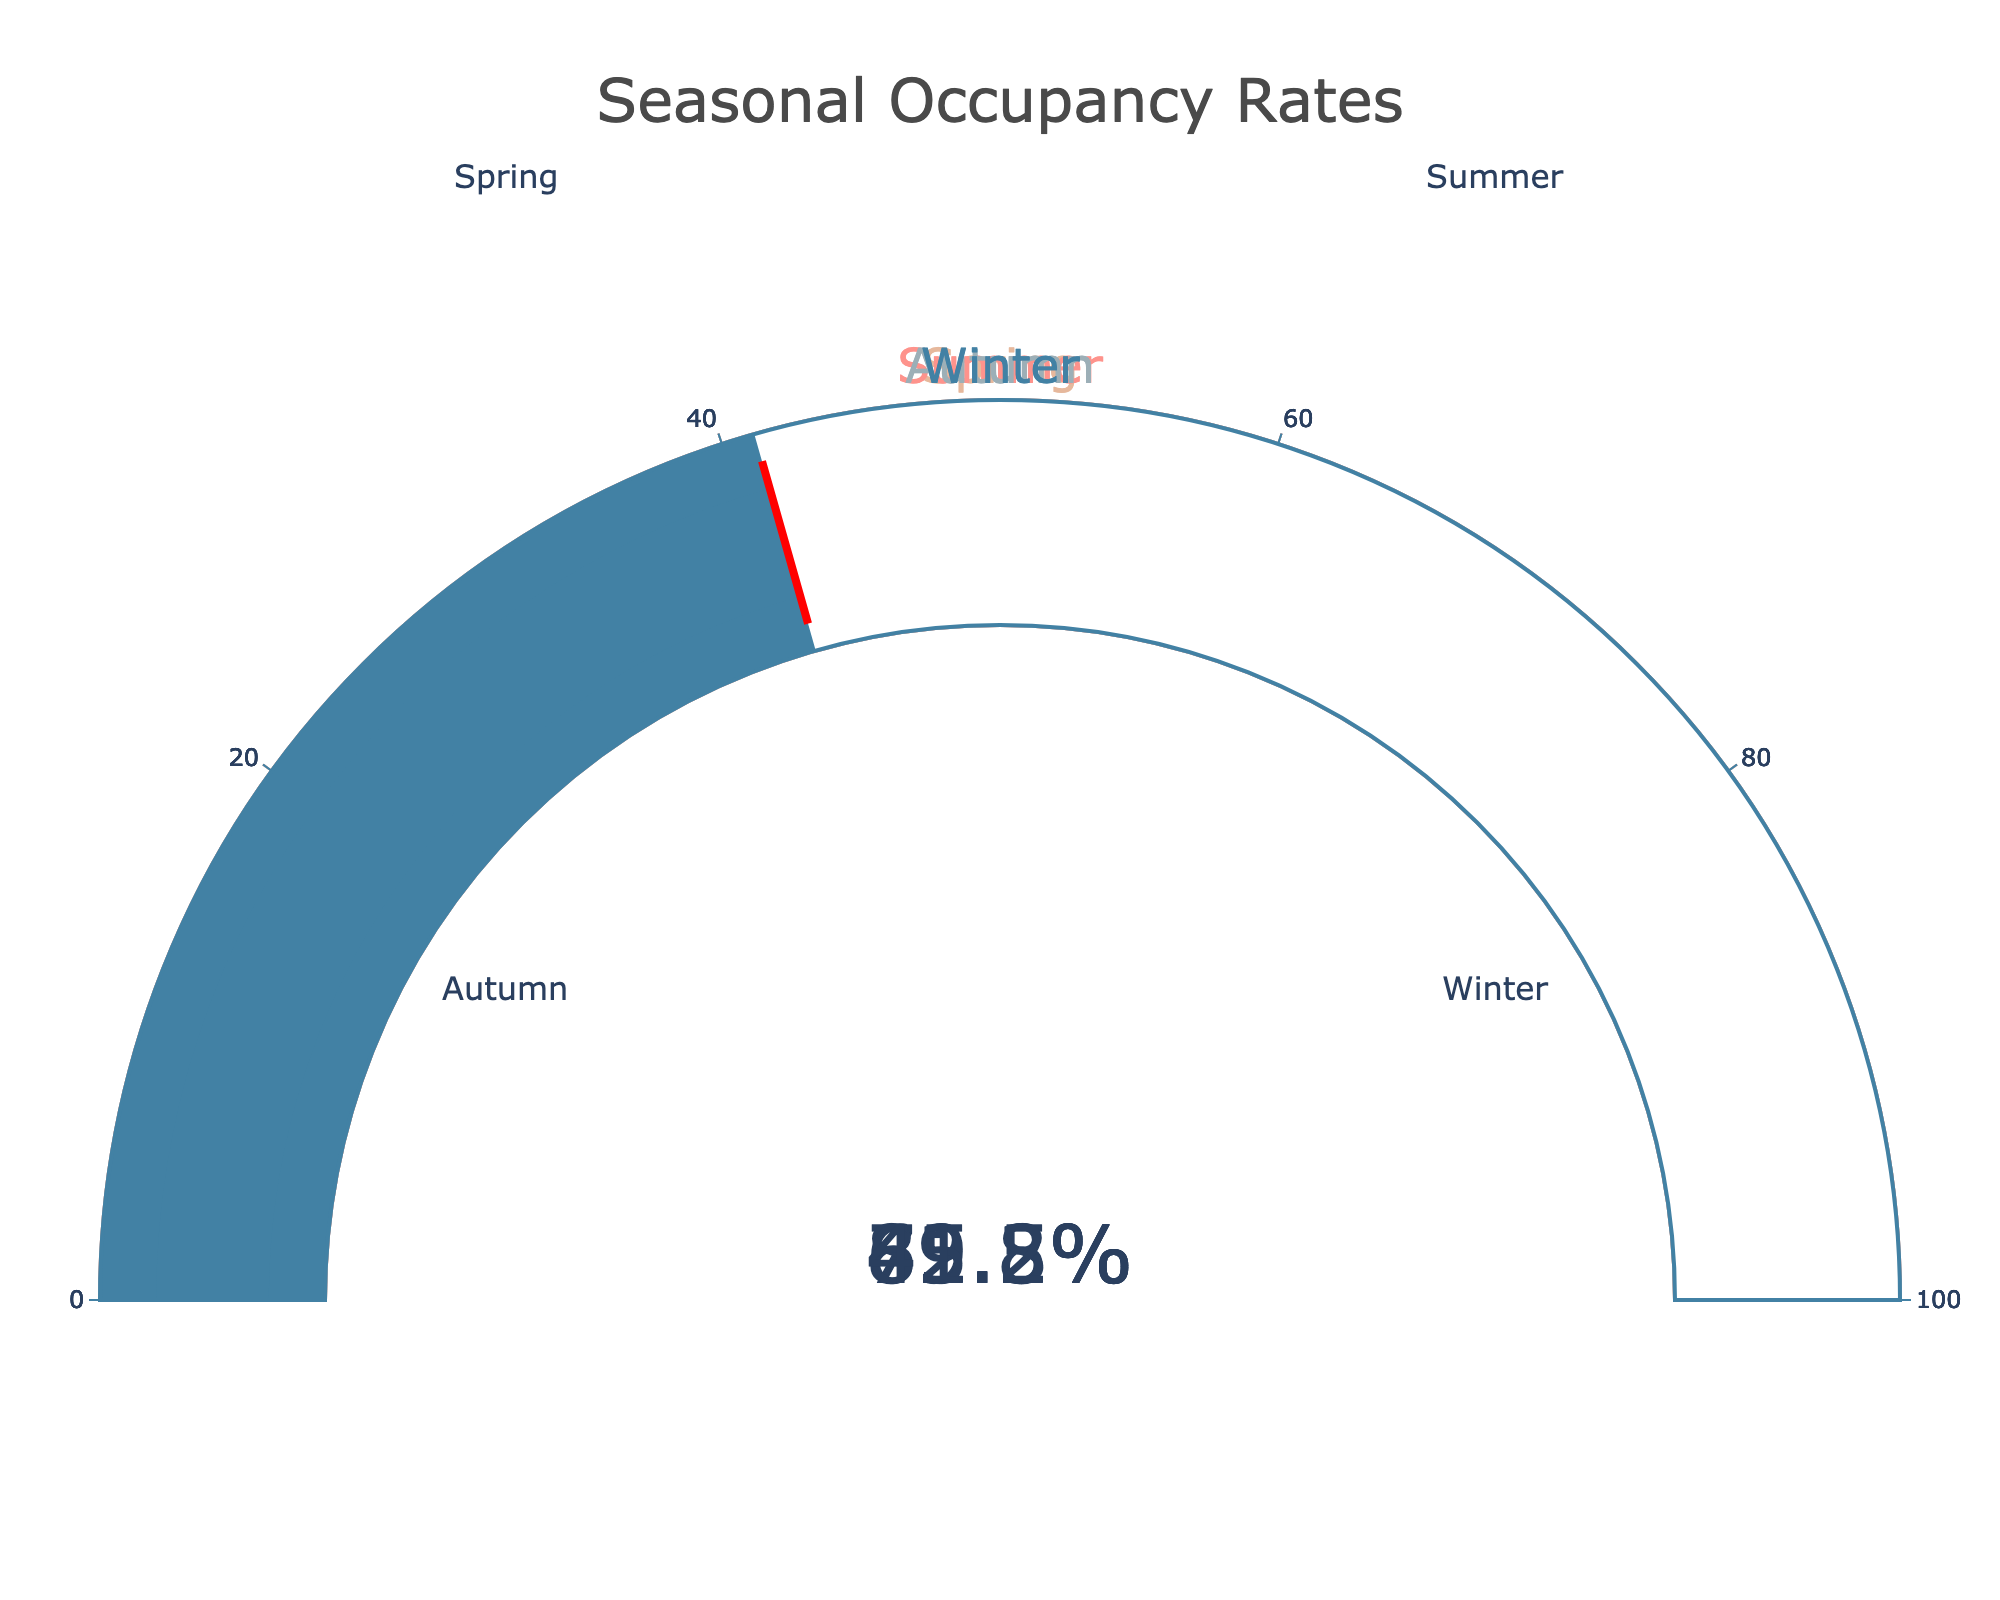Which season has the highest occupancy rate? Look at the gauges on the figure and identify the one with the highest percentage. Summer shows 89.3%.
Answer: Summer Which season has the lowest occupancy rate? Look at the gauges on the figure and identify the one with the lowest percentage. Winter shows 41.2%.
Answer: Winter What is the difference in occupancy rate between Summer and Winter? Subtract Winter's occupancy rate from Summer's occupancy rate: 89.3% - 41.2% = 48.1%.
Answer: 48.1% What is the average occupancy rate across all seasons? Add all the occupancy rates and divide by the number of seasons: (72.5 + 89.3 + 65.8 + 41.2) / 4 = 67.2%.
Answer: 67.2% Which seasons have an occupancy rate higher than 70%? Look at the gauges and identify the seasons with rates above 70%. Spring (72.5%) and Summer (89.3%) meet this criterion.
Answer: Spring and Summer By how much does Spring's occupancy rate exceed Winter's? Subtract Winter's occupancy rate from Spring's occupancy rate: 72.5% - 41.2% = 31.3%.
Answer: 31.3% What is the combined occupancy rate of Spring and Autumn? Add the occupancy rates of Spring and Autumn: 72.5% + 65.8% = 138.3%.
Answer: 138.3% How much lower is Autumn's occupancy rate compared to Spring's? Subtract Autumn's occupancy rate from Spring's: 72.5% - 65.8% = 6.7%.
Answer: 6.7% Which season's occupancy rate is closest to the average occupancy rate? Calculate the absolute differences between the occupancy rates and the average (67.2%), and find the smallest difference. Autumn's rate is 65.8%, a difference of 1.4%, which is closest to the average.
Answer: Autumn 